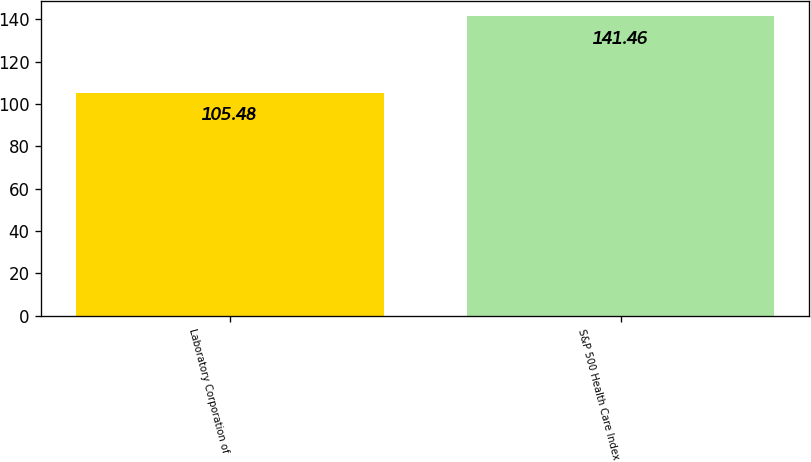Convert chart to OTSL. <chart><loc_0><loc_0><loc_500><loc_500><bar_chart><fcel>Laboratory Corporation of<fcel>S&P 500 Health Care Index<nl><fcel>105.48<fcel>141.46<nl></chart> 